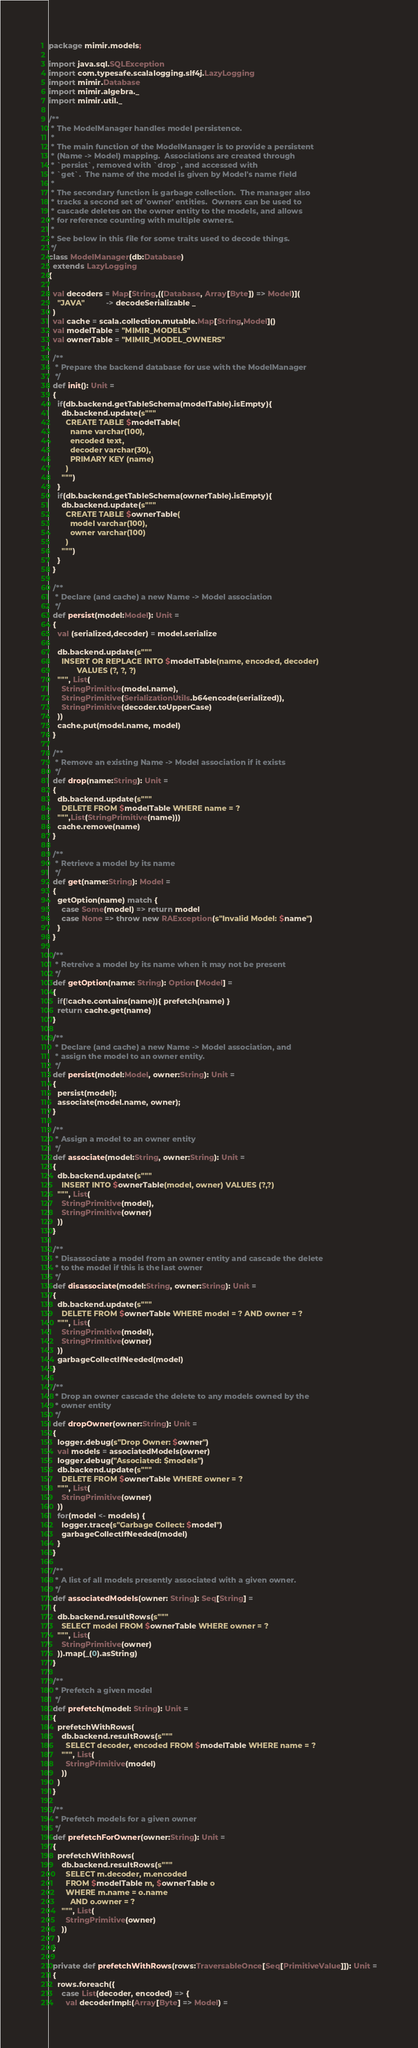<code> <loc_0><loc_0><loc_500><loc_500><_Scala_>package mimir.models;

import java.sql.SQLException
import com.typesafe.scalalogging.slf4j.LazyLogging
import mimir.Database
import mimir.algebra._
import mimir.util._

/**
 * The ModelManager handles model persistence.  
 *
 * The main function of the ModelManager is to provide a persistent
 * (Name -> Model) mapping.  Associations are created through
 * `persist`, removed with `drop`, and accessed with
 * `get`.  The name of the model is given by Model's name field
 *
 * The secondary function is garbage collection.  The manager also 
 * tracks a second set of 'owner' entities.  Owners can be used to
 * cascade deletes on the owner entity to the models, and allows
 * for reference counting with multiple owners.
 *
 * See below in this file for some traits used to decode things.
 */
class ModelManager(db:Database) 
  extends LazyLogging
{
  
  val decoders = Map[String,((Database, Array[Byte]) => Model)](
    "JAVA"          -> decodeSerializable _
  )
  val cache = scala.collection.mutable.Map[String,Model]()
  val modelTable = "MIMIR_MODELS"
  val ownerTable = "MIMIR_MODEL_OWNERS"

  /**
   * Prepare the backend database for use with the ModelManager
   */
  def init(): Unit =
  {
    if(db.backend.getTableSchema(modelTable).isEmpty){
      db.backend.update(s"""
        CREATE TABLE $modelTable(
          name varchar(100), 
          encoded text,
          decoder varchar(30),
          PRIMARY KEY (name)
        )
      """)
    }
    if(db.backend.getTableSchema(ownerTable).isEmpty){
      db.backend.update(s"""
        CREATE TABLE $ownerTable(
          model varchar(100), 
          owner varchar(100)
        )
      """)
    }
  }

  /**
   * Declare (and cache) a new Name -> Model association
   */
  def persist(model:Model): Unit =
  {
    val (serialized,decoder) = model.serialize

    db.backend.update(s"""
      INSERT OR REPLACE INTO $modelTable(name, encoded, decoder)
             VALUES (?, ?, ?)
    """, List(
      StringPrimitive(model.name),
      StringPrimitive(SerializationUtils.b64encode(serialized)),
      StringPrimitive(decoder.toUpperCase)
    ))
    cache.put(model.name, model)
  }

  /**
   * Remove an existing Name -> Model association if it exists
   */
  def drop(name:String): Unit =
  {
    db.backend.update(s"""
      DELETE FROM $modelTable WHERE name = ?
    """,List(StringPrimitive(name)))
    cache.remove(name)
  }

  /**
   * Retrieve a model by its name
   */
  def get(name:String): Model =
  {
    getOption(name) match {
      case Some(model) => return model
      case None => throw new RAException(s"Invalid Model: $name")
    }
  }

  /**
   * Retreive a model by its name when it may not be present
   */
  def getOption(name: String): Option[Model] =
  {
    if(!cache.contains(name)){ prefetch(name) }
    return cache.get(name)
  }

  /**
   * Declare (and cache) a new Name -> Model association, and 
   * assign the model to an owner entity.
   */
  def persist(model:Model, owner:String): Unit =
  {
    persist(model);
    associate(model.name, owner);
  }

  /**
   * Assign a model to an owner entity
   */
  def associate(model:String, owner:String): Unit =
  {
    db.backend.update(s"""
      INSERT INTO $ownerTable(model, owner) VALUES (?,?)
    """, List(
      StringPrimitive(model),
      StringPrimitive(owner)
    ))
  }

  /**
   * Disassociate a model from an owner entity and cascade the delete
   * to the model if this is the last owner
   */
  def disassociate(model:String, owner:String): Unit =
  {
    db.backend.update(s"""
      DELETE FROM $ownerTable WHERE model = ? AND owner = ?
    """, List(
      StringPrimitive(model),
      StringPrimitive(owner)
    ))
    garbageCollectIfNeeded(model)
  }

  /**
   * Drop an owner cascade the delete to any models owned by the
   * owner entity
   */
  def dropOwner(owner:String): Unit =
  {
    logger.debug(s"Drop Owner: $owner")
    val models = associatedModels(owner)
    logger.debug("Associated: $models")
    db.backend.update(s"""
      DELETE FROM $ownerTable WHERE owner = ?
    """, List(
      StringPrimitive(owner)
    ))
    for(model <- models) {
      logger.trace(s"Garbage Collect: $model")
      garbageCollectIfNeeded(model)
    }
  }

  /**
   * A list of all models presently associated with a given owner.
   */
  def associatedModels(owner: String): Seq[String] =
  {
    db.backend.resultRows(s"""
      SELECT model FROM $ownerTable WHERE owner = ?
    """, List(
      StringPrimitive(owner)
    )).map(_(0).asString)
  }

  /**
   * Prefetch a given model
   */
  def prefetch(model: String): Unit =
  {
    prefetchWithRows(
      db.backend.resultRows(s"""
        SELECT decoder, encoded FROM $modelTable WHERE name = ?
      """, List(
        StringPrimitive(model)
      ))
    )
  }

  /**
   * Prefetch models for a given owner
   */
  def prefetchForOwner(owner:String): Unit =
  {
    prefetchWithRows(
      db.backend.resultRows(s"""
        SELECT m.decoder, m.encoded 
        FROM $modelTable m, $ownerTable o
        WHERE m.name = o.name 
          AND o.owner = ?
      """, List(
        StringPrimitive(owner)
      ))
    )
  }

  private def prefetchWithRows(rows:TraversableOnce[Seq[PrimitiveValue]]): Unit =
  {
    rows.foreach({
      case List(decoder, encoded) => {
        val decoderImpl:(Array[Byte] => Model) = </code> 